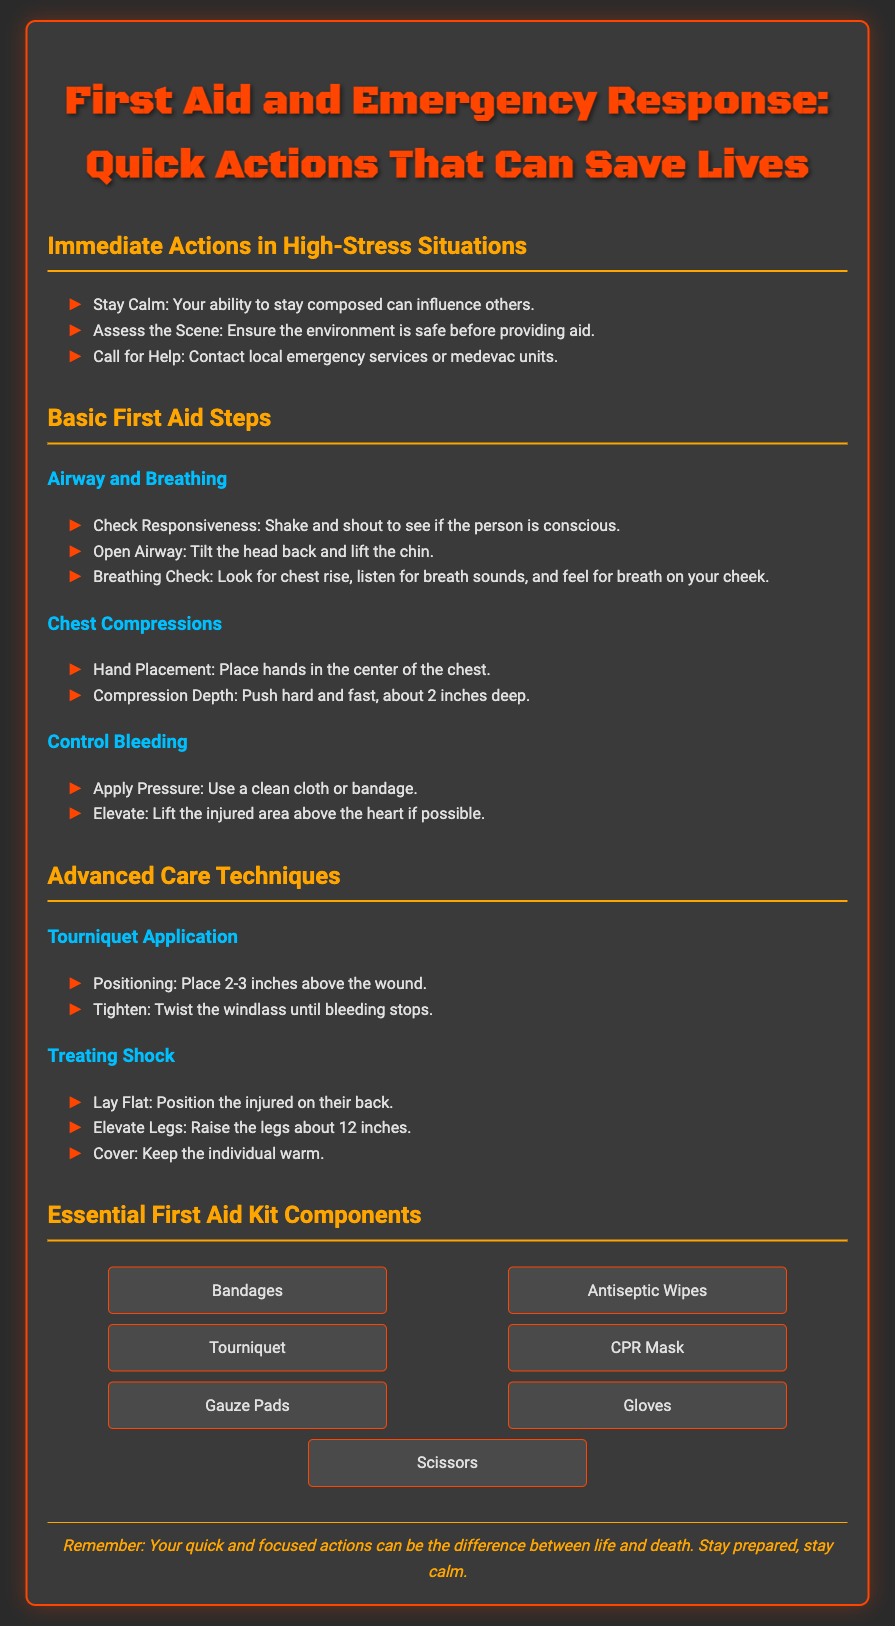What is the title of the flyer? The title is presented prominently at the top of the document.
Answer: First Aid and Emergency Response: Quick Actions That Can Save Lives How many immediate actions are listed? The number of actions is visible in the section titled "Immediate Actions in High-Stress Situations."
Answer: Three What is the first step in Basic First Aid Steps for Airway and Breathing? The first step is explicitly mentioned in the relevant section.
Answer: Check Responsiveness What should be applied to control bleeding? This is described in the section dedicated to controlling bleeding.
Answer: Pressure What is the purpose of elevating legs when treating shock? The purpose is outlined in the section on Treating Shock.
Answer: Improve circulation Which item is NOT listed as an essential first aid kit component? This can be deduced from the list of components provided in the corresponding section.
Answer: Ice pack What should you do before providing aid? This information is emphasized in the immediate actions section.
Answer: Assess the Scene What is the color of the text used for headings? The color can be identified by analyzing the styling directives for heading elements.
Answer: Orange 